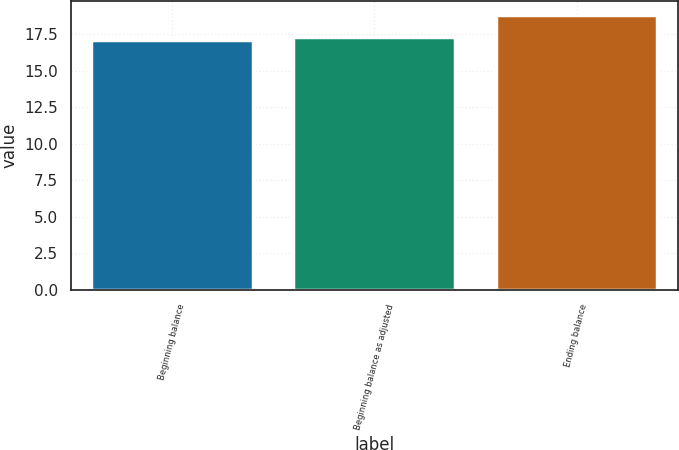<chart> <loc_0><loc_0><loc_500><loc_500><bar_chart><fcel>Beginning balance<fcel>Beginning balance as adjusted<fcel>Ending balance<nl><fcel>17.1<fcel>17.27<fcel>18.8<nl></chart> 